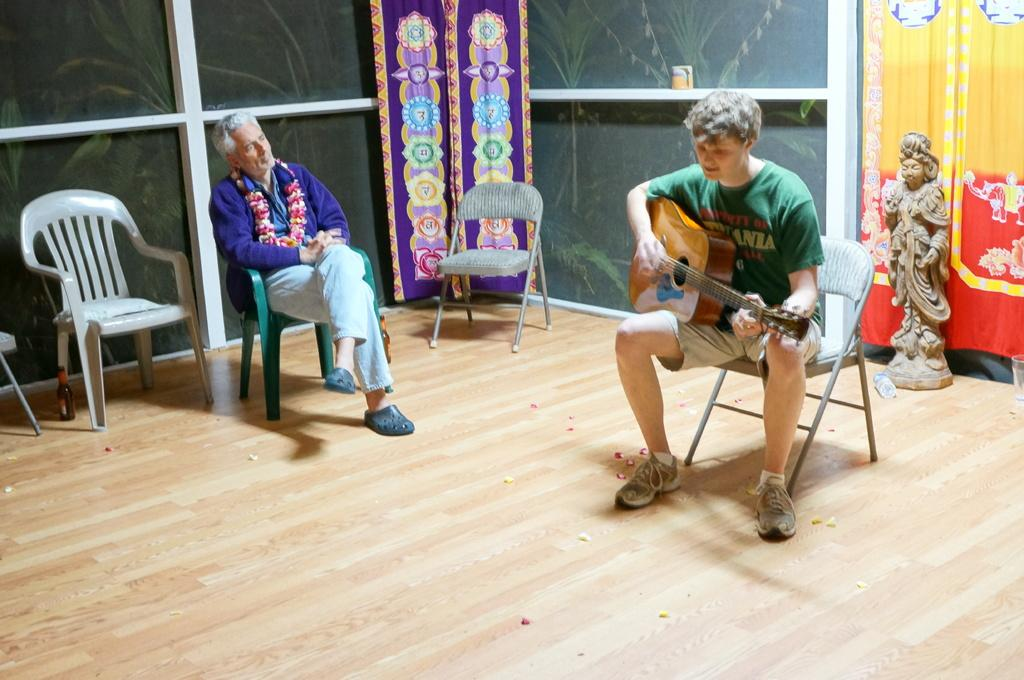What is the man in the image doing? The man is sitting on a chair in the image. Can you describe the other person in the image? The other person is playing the guitar. How many pizzas is the sister holding in the image? There is no sister or pizzas present in the image. 